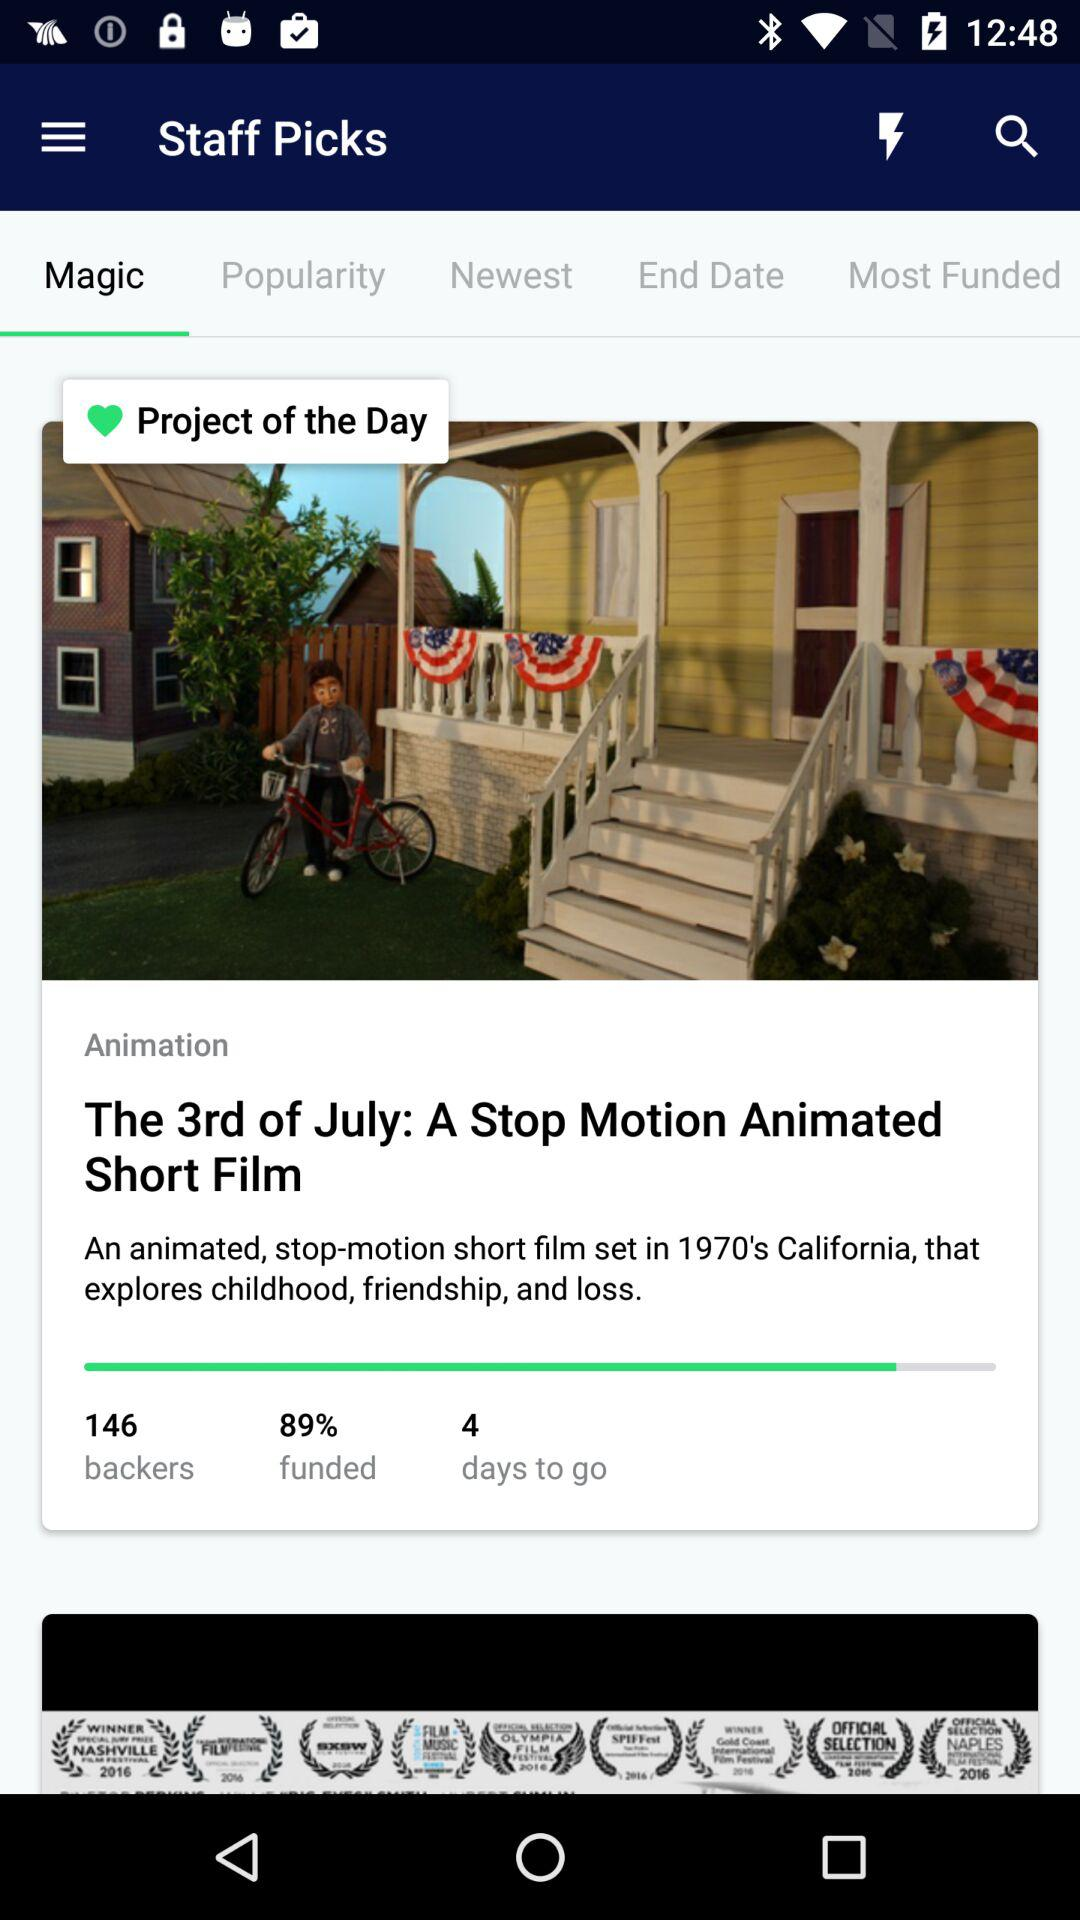How many days are left for the movie to be released? There are 4 days left for the movie to be released. 